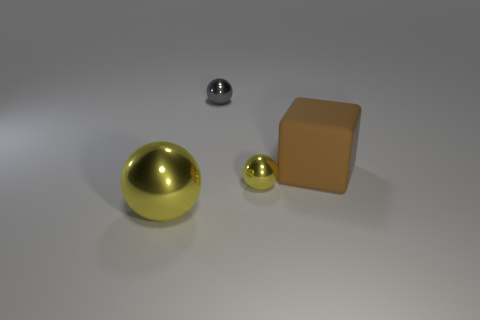What number of other things are there of the same size as the brown cube?
Provide a short and direct response. 1. Are the brown block and the small gray thing made of the same material?
Your answer should be compact. No. How many big yellow things have the same material as the gray sphere?
Your answer should be compact. 1. There is a brown thing; is it the same size as the metal thing behind the brown block?
Ensure brevity in your answer.  No. The object that is both behind the small yellow metal sphere and to the left of the large rubber cube is what color?
Provide a short and direct response. Gray. There is a yellow shiny thing that is behind the big yellow thing; are there any brown things in front of it?
Your answer should be compact. No. Are there the same number of big yellow metallic spheres that are in front of the small yellow sphere and big brown blocks?
Your answer should be compact. Yes. How many metallic spheres are behind the large thing that is on the left side of the tiny shiny sphere behind the big brown cube?
Offer a terse response. 2. Is there a shiny thing of the same size as the brown cube?
Offer a very short reply. Yes. Are there fewer small gray objects behind the matte object than tiny yellow metallic balls?
Give a very brief answer. No. 